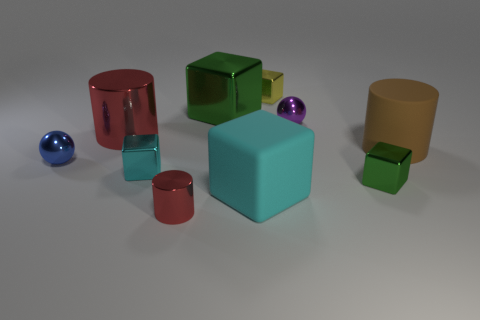Subtract 1 blocks. How many blocks are left? 4 Subtract all purple spheres. Subtract all gray cylinders. How many spheres are left? 1 Subtract all cylinders. How many objects are left? 7 Subtract 2 cyan blocks. How many objects are left? 8 Subtract all big green metallic cylinders. Subtract all small blocks. How many objects are left? 7 Add 8 tiny yellow shiny objects. How many tiny yellow shiny objects are left? 9 Add 1 large blue cylinders. How many large blue cylinders exist? 1 